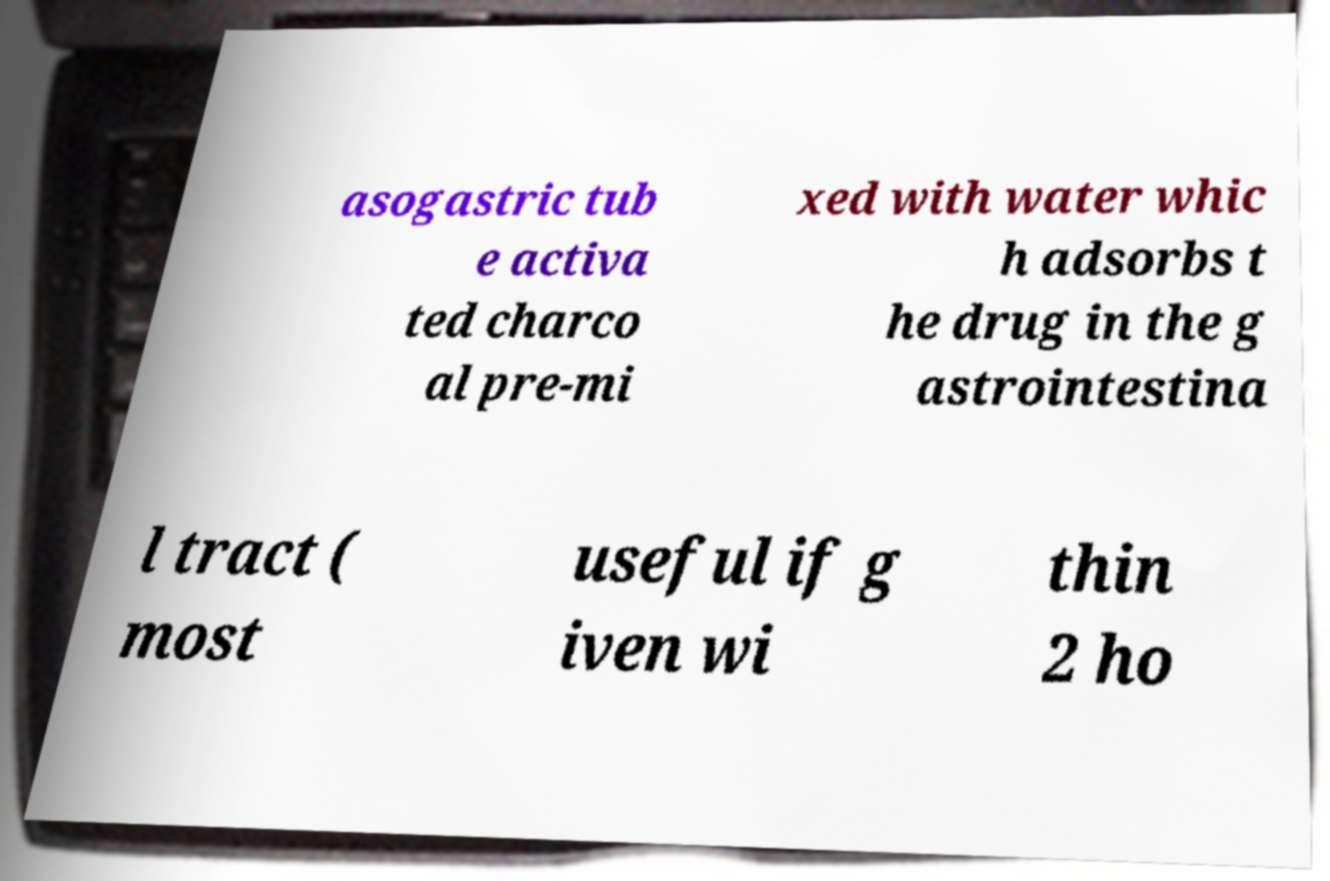Could you assist in decoding the text presented in this image and type it out clearly? asogastric tub e activa ted charco al pre-mi xed with water whic h adsorbs t he drug in the g astrointestina l tract ( most useful if g iven wi thin 2 ho 